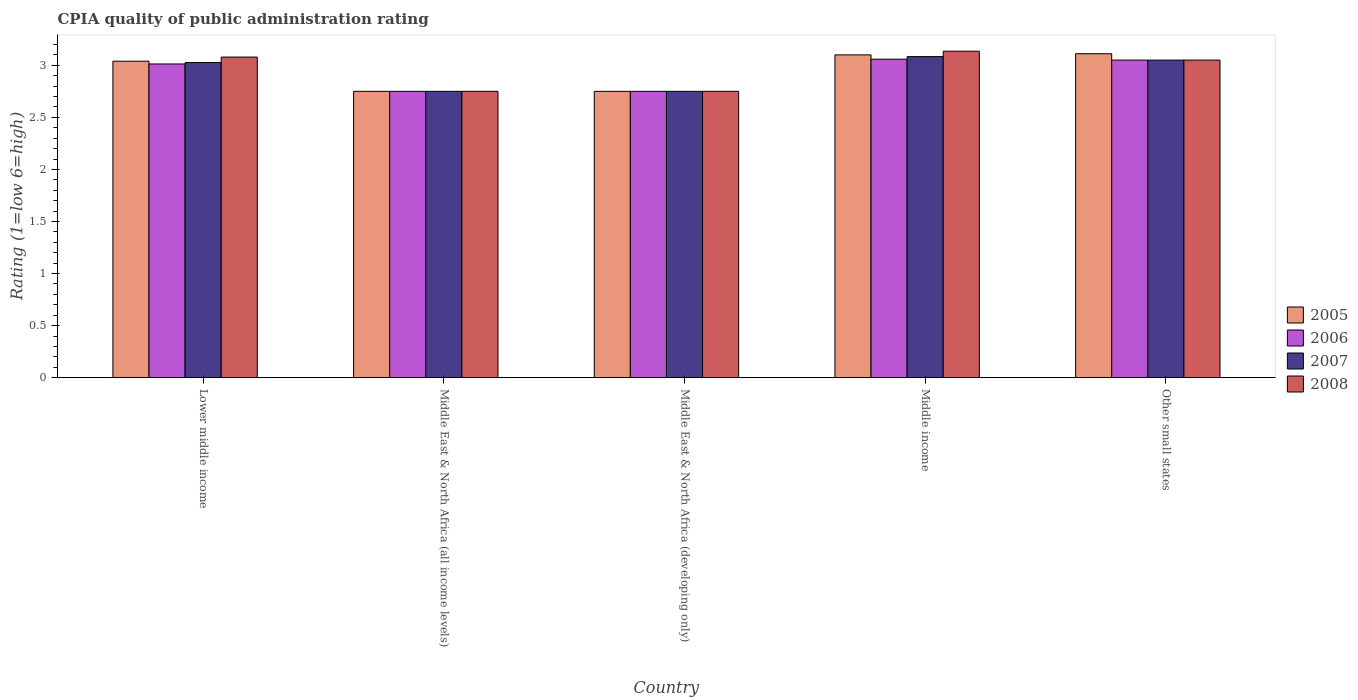What is the label of the 4th group of bars from the left?
Provide a succinct answer. Middle income. What is the CPIA rating in 2006 in Middle income?
Your answer should be very brief. 3.06. Across all countries, what is the maximum CPIA rating in 2008?
Your answer should be compact. 3.14. Across all countries, what is the minimum CPIA rating in 2006?
Make the answer very short. 2.75. In which country was the CPIA rating in 2007 maximum?
Your answer should be very brief. Middle income. In which country was the CPIA rating in 2008 minimum?
Make the answer very short. Middle East & North Africa (all income levels). What is the total CPIA rating in 2008 in the graph?
Offer a terse response. 14.76. What is the difference between the CPIA rating in 2008 in Middle East & North Africa (all income levels) and that in Other small states?
Your answer should be very brief. -0.3. What is the difference between the CPIA rating in 2006 in Middle income and the CPIA rating in 2005 in Other small states?
Keep it short and to the point. -0.05. What is the average CPIA rating in 2007 per country?
Your answer should be very brief. 2.93. What is the difference between the CPIA rating of/in 2007 and CPIA rating of/in 2005 in Middle East & North Africa (all income levels)?
Your response must be concise. 0. What is the ratio of the CPIA rating in 2007 in Lower middle income to that in Middle income?
Provide a short and direct response. 0.98. Is the CPIA rating in 2005 in Middle East & North Africa (developing only) less than that in Middle income?
Provide a succinct answer. Yes. Is the difference between the CPIA rating in 2007 in Lower middle income and Middle East & North Africa (developing only) greater than the difference between the CPIA rating in 2005 in Lower middle income and Middle East & North Africa (developing only)?
Offer a terse response. No. What is the difference between the highest and the second highest CPIA rating in 2006?
Your response must be concise. -0.01. What is the difference between the highest and the lowest CPIA rating in 2006?
Offer a very short reply. 0.31. Is the sum of the CPIA rating in 2008 in Middle East & North Africa (all income levels) and Other small states greater than the maximum CPIA rating in 2005 across all countries?
Ensure brevity in your answer.  Yes. Is it the case that in every country, the sum of the CPIA rating in 2006 and CPIA rating in 2005 is greater than the sum of CPIA rating in 2008 and CPIA rating in 2007?
Provide a succinct answer. No. What does the 1st bar from the left in Lower middle income represents?
Provide a short and direct response. 2005. How many bars are there?
Keep it short and to the point. 20. How many countries are there in the graph?
Provide a succinct answer. 5. Are the values on the major ticks of Y-axis written in scientific E-notation?
Make the answer very short. No. Does the graph contain any zero values?
Make the answer very short. No. Where does the legend appear in the graph?
Your response must be concise. Center right. How many legend labels are there?
Your response must be concise. 4. What is the title of the graph?
Your answer should be very brief. CPIA quality of public administration rating. Does "1997" appear as one of the legend labels in the graph?
Ensure brevity in your answer.  No. What is the label or title of the Y-axis?
Give a very brief answer. Rating (1=low 6=high). What is the Rating (1=low 6=high) in 2005 in Lower middle income?
Your answer should be compact. 3.04. What is the Rating (1=low 6=high) of 2006 in Lower middle income?
Give a very brief answer. 3.01. What is the Rating (1=low 6=high) of 2007 in Lower middle income?
Ensure brevity in your answer.  3.03. What is the Rating (1=low 6=high) of 2008 in Lower middle income?
Offer a terse response. 3.08. What is the Rating (1=low 6=high) of 2005 in Middle East & North Africa (all income levels)?
Make the answer very short. 2.75. What is the Rating (1=low 6=high) in 2006 in Middle East & North Africa (all income levels)?
Offer a terse response. 2.75. What is the Rating (1=low 6=high) of 2007 in Middle East & North Africa (all income levels)?
Your answer should be compact. 2.75. What is the Rating (1=low 6=high) in 2008 in Middle East & North Africa (all income levels)?
Your answer should be compact. 2.75. What is the Rating (1=low 6=high) in 2005 in Middle East & North Africa (developing only)?
Offer a very short reply. 2.75. What is the Rating (1=low 6=high) of 2006 in Middle East & North Africa (developing only)?
Offer a terse response. 2.75. What is the Rating (1=low 6=high) in 2007 in Middle East & North Africa (developing only)?
Keep it short and to the point. 2.75. What is the Rating (1=low 6=high) in 2008 in Middle East & North Africa (developing only)?
Provide a short and direct response. 2.75. What is the Rating (1=low 6=high) in 2005 in Middle income?
Offer a terse response. 3.1. What is the Rating (1=low 6=high) of 2006 in Middle income?
Your answer should be compact. 3.06. What is the Rating (1=low 6=high) of 2007 in Middle income?
Make the answer very short. 3.08. What is the Rating (1=low 6=high) in 2008 in Middle income?
Keep it short and to the point. 3.14. What is the Rating (1=low 6=high) in 2005 in Other small states?
Offer a terse response. 3.11. What is the Rating (1=low 6=high) of 2006 in Other small states?
Keep it short and to the point. 3.05. What is the Rating (1=low 6=high) in 2007 in Other small states?
Keep it short and to the point. 3.05. What is the Rating (1=low 6=high) in 2008 in Other small states?
Ensure brevity in your answer.  3.05. Across all countries, what is the maximum Rating (1=low 6=high) of 2005?
Keep it short and to the point. 3.11. Across all countries, what is the maximum Rating (1=low 6=high) of 2006?
Keep it short and to the point. 3.06. Across all countries, what is the maximum Rating (1=low 6=high) in 2007?
Your answer should be very brief. 3.08. Across all countries, what is the maximum Rating (1=low 6=high) of 2008?
Your answer should be very brief. 3.14. Across all countries, what is the minimum Rating (1=low 6=high) of 2005?
Ensure brevity in your answer.  2.75. Across all countries, what is the minimum Rating (1=low 6=high) in 2006?
Keep it short and to the point. 2.75. Across all countries, what is the minimum Rating (1=low 6=high) of 2007?
Offer a very short reply. 2.75. Across all countries, what is the minimum Rating (1=low 6=high) in 2008?
Provide a succinct answer. 2.75. What is the total Rating (1=low 6=high) of 2005 in the graph?
Offer a very short reply. 14.75. What is the total Rating (1=low 6=high) of 2006 in the graph?
Offer a terse response. 14.62. What is the total Rating (1=low 6=high) in 2007 in the graph?
Provide a short and direct response. 14.66. What is the total Rating (1=low 6=high) of 2008 in the graph?
Your answer should be compact. 14.76. What is the difference between the Rating (1=low 6=high) of 2005 in Lower middle income and that in Middle East & North Africa (all income levels)?
Offer a terse response. 0.29. What is the difference between the Rating (1=low 6=high) of 2006 in Lower middle income and that in Middle East & North Africa (all income levels)?
Offer a terse response. 0.26. What is the difference between the Rating (1=low 6=high) of 2007 in Lower middle income and that in Middle East & North Africa (all income levels)?
Offer a terse response. 0.28. What is the difference between the Rating (1=low 6=high) of 2008 in Lower middle income and that in Middle East & North Africa (all income levels)?
Your answer should be compact. 0.33. What is the difference between the Rating (1=low 6=high) in 2005 in Lower middle income and that in Middle East & North Africa (developing only)?
Your answer should be very brief. 0.29. What is the difference between the Rating (1=low 6=high) in 2006 in Lower middle income and that in Middle East & North Africa (developing only)?
Your response must be concise. 0.26. What is the difference between the Rating (1=low 6=high) of 2007 in Lower middle income and that in Middle East & North Africa (developing only)?
Make the answer very short. 0.28. What is the difference between the Rating (1=low 6=high) in 2008 in Lower middle income and that in Middle East & North Africa (developing only)?
Offer a terse response. 0.33. What is the difference between the Rating (1=low 6=high) of 2005 in Lower middle income and that in Middle income?
Offer a terse response. -0.06. What is the difference between the Rating (1=low 6=high) in 2006 in Lower middle income and that in Middle income?
Provide a short and direct response. -0.05. What is the difference between the Rating (1=low 6=high) of 2007 in Lower middle income and that in Middle income?
Keep it short and to the point. -0.06. What is the difference between the Rating (1=low 6=high) of 2008 in Lower middle income and that in Middle income?
Make the answer very short. -0.06. What is the difference between the Rating (1=low 6=high) in 2005 in Lower middle income and that in Other small states?
Give a very brief answer. -0.07. What is the difference between the Rating (1=low 6=high) in 2006 in Lower middle income and that in Other small states?
Offer a very short reply. -0.04. What is the difference between the Rating (1=low 6=high) of 2007 in Lower middle income and that in Other small states?
Your answer should be compact. -0.02. What is the difference between the Rating (1=low 6=high) of 2008 in Lower middle income and that in Other small states?
Provide a short and direct response. 0.03. What is the difference between the Rating (1=low 6=high) of 2006 in Middle East & North Africa (all income levels) and that in Middle East & North Africa (developing only)?
Offer a very short reply. 0. What is the difference between the Rating (1=low 6=high) in 2007 in Middle East & North Africa (all income levels) and that in Middle East & North Africa (developing only)?
Provide a succinct answer. 0. What is the difference between the Rating (1=low 6=high) of 2005 in Middle East & North Africa (all income levels) and that in Middle income?
Your answer should be compact. -0.35. What is the difference between the Rating (1=low 6=high) in 2006 in Middle East & North Africa (all income levels) and that in Middle income?
Your answer should be very brief. -0.31. What is the difference between the Rating (1=low 6=high) in 2007 in Middle East & North Africa (all income levels) and that in Middle income?
Keep it short and to the point. -0.33. What is the difference between the Rating (1=low 6=high) in 2008 in Middle East & North Africa (all income levels) and that in Middle income?
Make the answer very short. -0.39. What is the difference between the Rating (1=low 6=high) in 2005 in Middle East & North Africa (all income levels) and that in Other small states?
Keep it short and to the point. -0.36. What is the difference between the Rating (1=low 6=high) of 2006 in Middle East & North Africa (all income levels) and that in Other small states?
Offer a terse response. -0.3. What is the difference between the Rating (1=low 6=high) in 2007 in Middle East & North Africa (all income levels) and that in Other small states?
Your answer should be compact. -0.3. What is the difference between the Rating (1=low 6=high) of 2005 in Middle East & North Africa (developing only) and that in Middle income?
Ensure brevity in your answer.  -0.35. What is the difference between the Rating (1=low 6=high) of 2006 in Middle East & North Africa (developing only) and that in Middle income?
Make the answer very short. -0.31. What is the difference between the Rating (1=low 6=high) in 2008 in Middle East & North Africa (developing only) and that in Middle income?
Offer a terse response. -0.39. What is the difference between the Rating (1=low 6=high) of 2005 in Middle East & North Africa (developing only) and that in Other small states?
Make the answer very short. -0.36. What is the difference between the Rating (1=low 6=high) in 2008 in Middle East & North Africa (developing only) and that in Other small states?
Offer a very short reply. -0.3. What is the difference between the Rating (1=low 6=high) in 2005 in Middle income and that in Other small states?
Provide a succinct answer. -0.01. What is the difference between the Rating (1=low 6=high) in 2006 in Middle income and that in Other small states?
Make the answer very short. 0.01. What is the difference between the Rating (1=low 6=high) in 2007 in Middle income and that in Other small states?
Provide a succinct answer. 0.03. What is the difference between the Rating (1=low 6=high) in 2008 in Middle income and that in Other small states?
Your response must be concise. 0.09. What is the difference between the Rating (1=low 6=high) in 2005 in Lower middle income and the Rating (1=low 6=high) in 2006 in Middle East & North Africa (all income levels)?
Provide a succinct answer. 0.29. What is the difference between the Rating (1=low 6=high) of 2005 in Lower middle income and the Rating (1=low 6=high) of 2007 in Middle East & North Africa (all income levels)?
Offer a very short reply. 0.29. What is the difference between the Rating (1=low 6=high) of 2005 in Lower middle income and the Rating (1=low 6=high) of 2008 in Middle East & North Africa (all income levels)?
Provide a succinct answer. 0.29. What is the difference between the Rating (1=low 6=high) of 2006 in Lower middle income and the Rating (1=low 6=high) of 2007 in Middle East & North Africa (all income levels)?
Your response must be concise. 0.26. What is the difference between the Rating (1=low 6=high) in 2006 in Lower middle income and the Rating (1=low 6=high) in 2008 in Middle East & North Africa (all income levels)?
Offer a terse response. 0.26. What is the difference between the Rating (1=low 6=high) in 2007 in Lower middle income and the Rating (1=low 6=high) in 2008 in Middle East & North Africa (all income levels)?
Give a very brief answer. 0.28. What is the difference between the Rating (1=low 6=high) in 2005 in Lower middle income and the Rating (1=low 6=high) in 2006 in Middle East & North Africa (developing only)?
Offer a terse response. 0.29. What is the difference between the Rating (1=low 6=high) in 2005 in Lower middle income and the Rating (1=low 6=high) in 2007 in Middle East & North Africa (developing only)?
Keep it short and to the point. 0.29. What is the difference between the Rating (1=low 6=high) of 2005 in Lower middle income and the Rating (1=low 6=high) of 2008 in Middle East & North Africa (developing only)?
Your answer should be compact. 0.29. What is the difference between the Rating (1=low 6=high) in 2006 in Lower middle income and the Rating (1=low 6=high) in 2007 in Middle East & North Africa (developing only)?
Provide a succinct answer. 0.26. What is the difference between the Rating (1=low 6=high) in 2006 in Lower middle income and the Rating (1=low 6=high) in 2008 in Middle East & North Africa (developing only)?
Provide a short and direct response. 0.26. What is the difference between the Rating (1=low 6=high) of 2007 in Lower middle income and the Rating (1=low 6=high) of 2008 in Middle East & North Africa (developing only)?
Ensure brevity in your answer.  0.28. What is the difference between the Rating (1=low 6=high) of 2005 in Lower middle income and the Rating (1=low 6=high) of 2006 in Middle income?
Offer a very short reply. -0.02. What is the difference between the Rating (1=low 6=high) in 2005 in Lower middle income and the Rating (1=low 6=high) in 2007 in Middle income?
Provide a succinct answer. -0.04. What is the difference between the Rating (1=low 6=high) in 2005 in Lower middle income and the Rating (1=low 6=high) in 2008 in Middle income?
Give a very brief answer. -0.1. What is the difference between the Rating (1=low 6=high) in 2006 in Lower middle income and the Rating (1=low 6=high) in 2007 in Middle income?
Ensure brevity in your answer.  -0.07. What is the difference between the Rating (1=low 6=high) in 2006 in Lower middle income and the Rating (1=low 6=high) in 2008 in Middle income?
Make the answer very short. -0.12. What is the difference between the Rating (1=low 6=high) in 2007 in Lower middle income and the Rating (1=low 6=high) in 2008 in Middle income?
Ensure brevity in your answer.  -0.11. What is the difference between the Rating (1=low 6=high) of 2005 in Lower middle income and the Rating (1=low 6=high) of 2006 in Other small states?
Your answer should be compact. -0.01. What is the difference between the Rating (1=low 6=high) in 2005 in Lower middle income and the Rating (1=low 6=high) in 2007 in Other small states?
Your answer should be compact. -0.01. What is the difference between the Rating (1=low 6=high) in 2005 in Lower middle income and the Rating (1=low 6=high) in 2008 in Other small states?
Keep it short and to the point. -0.01. What is the difference between the Rating (1=low 6=high) in 2006 in Lower middle income and the Rating (1=low 6=high) in 2007 in Other small states?
Keep it short and to the point. -0.04. What is the difference between the Rating (1=low 6=high) of 2006 in Lower middle income and the Rating (1=low 6=high) of 2008 in Other small states?
Provide a succinct answer. -0.04. What is the difference between the Rating (1=low 6=high) of 2007 in Lower middle income and the Rating (1=low 6=high) of 2008 in Other small states?
Your answer should be compact. -0.02. What is the difference between the Rating (1=low 6=high) of 2006 in Middle East & North Africa (all income levels) and the Rating (1=low 6=high) of 2007 in Middle East & North Africa (developing only)?
Provide a succinct answer. 0. What is the difference between the Rating (1=low 6=high) of 2006 in Middle East & North Africa (all income levels) and the Rating (1=low 6=high) of 2008 in Middle East & North Africa (developing only)?
Your response must be concise. 0. What is the difference between the Rating (1=low 6=high) of 2005 in Middle East & North Africa (all income levels) and the Rating (1=low 6=high) of 2006 in Middle income?
Your answer should be compact. -0.31. What is the difference between the Rating (1=low 6=high) in 2005 in Middle East & North Africa (all income levels) and the Rating (1=low 6=high) in 2008 in Middle income?
Provide a short and direct response. -0.39. What is the difference between the Rating (1=low 6=high) in 2006 in Middle East & North Africa (all income levels) and the Rating (1=low 6=high) in 2008 in Middle income?
Your answer should be compact. -0.39. What is the difference between the Rating (1=low 6=high) of 2007 in Middle East & North Africa (all income levels) and the Rating (1=low 6=high) of 2008 in Middle income?
Offer a very short reply. -0.39. What is the difference between the Rating (1=low 6=high) of 2005 in Middle East & North Africa (all income levels) and the Rating (1=low 6=high) of 2006 in Other small states?
Keep it short and to the point. -0.3. What is the difference between the Rating (1=low 6=high) of 2005 in Middle East & North Africa (all income levels) and the Rating (1=low 6=high) of 2007 in Other small states?
Offer a terse response. -0.3. What is the difference between the Rating (1=low 6=high) in 2005 in Middle East & North Africa (developing only) and the Rating (1=low 6=high) in 2006 in Middle income?
Make the answer very short. -0.31. What is the difference between the Rating (1=low 6=high) of 2005 in Middle East & North Africa (developing only) and the Rating (1=low 6=high) of 2008 in Middle income?
Provide a short and direct response. -0.39. What is the difference between the Rating (1=low 6=high) of 2006 in Middle East & North Africa (developing only) and the Rating (1=low 6=high) of 2007 in Middle income?
Your answer should be compact. -0.33. What is the difference between the Rating (1=low 6=high) of 2006 in Middle East & North Africa (developing only) and the Rating (1=low 6=high) of 2008 in Middle income?
Your response must be concise. -0.39. What is the difference between the Rating (1=low 6=high) in 2007 in Middle East & North Africa (developing only) and the Rating (1=low 6=high) in 2008 in Middle income?
Keep it short and to the point. -0.39. What is the difference between the Rating (1=low 6=high) in 2005 in Middle East & North Africa (developing only) and the Rating (1=low 6=high) in 2006 in Other small states?
Your answer should be compact. -0.3. What is the difference between the Rating (1=low 6=high) of 2005 in Middle East & North Africa (developing only) and the Rating (1=low 6=high) of 2007 in Other small states?
Your response must be concise. -0.3. What is the difference between the Rating (1=low 6=high) of 2005 in Middle East & North Africa (developing only) and the Rating (1=low 6=high) of 2008 in Other small states?
Keep it short and to the point. -0.3. What is the difference between the Rating (1=low 6=high) in 2006 in Middle East & North Africa (developing only) and the Rating (1=low 6=high) in 2007 in Other small states?
Keep it short and to the point. -0.3. What is the difference between the Rating (1=low 6=high) of 2006 in Middle East & North Africa (developing only) and the Rating (1=low 6=high) of 2008 in Other small states?
Offer a terse response. -0.3. What is the difference between the Rating (1=low 6=high) in 2007 in Middle East & North Africa (developing only) and the Rating (1=low 6=high) in 2008 in Other small states?
Make the answer very short. -0.3. What is the difference between the Rating (1=low 6=high) in 2005 in Middle income and the Rating (1=low 6=high) in 2007 in Other small states?
Provide a succinct answer. 0.05. What is the difference between the Rating (1=low 6=high) in 2006 in Middle income and the Rating (1=low 6=high) in 2007 in Other small states?
Keep it short and to the point. 0.01. What is the difference between the Rating (1=low 6=high) of 2006 in Middle income and the Rating (1=low 6=high) of 2008 in Other small states?
Offer a terse response. 0.01. What is the average Rating (1=low 6=high) of 2005 per country?
Provide a succinct answer. 2.95. What is the average Rating (1=low 6=high) of 2006 per country?
Keep it short and to the point. 2.92. What is the average Rating (1=low 6=high) in 2007 per country?
Give a very brief answer. 2.93. What is the average Rating (1=low 6=high) of 2008 per country?
Your answer should be compact. 2.95. What is the difference between the Rating (1=low 6=high) of 2005 and Rating (1=low 6=high) of 2006 in Lower middle income?
Make the answer very short. 0.03. What is the difference between the Rating (1=low 6=high) of 2005 and Rating (1=low 6=high) of 2007 in Lower middle income?
Offer a very short reply. 0.01. What is the difference between the Rating (1=low 6=high) in 2005 and Rating (1=low 6=high) in 2008 in Lower middle income?
Your response must be concise. -0.04. What is the difference between the Rating (1=low 6=high) of 2006 and Rating (1=low 6=high) of 2007 in Lower middle income?
Your response must be concise. -0.01. What is the difference between the Rating (1=low 6=high) in 2006 and Rating (1=low 6=high) in 2008 in Lower middle income?
Ensure brevity in your answer.  -0.07. What is the difference between the Rating (1=low 6=high) in 2007 and Rating (1=low 6=high) in 2008 in Lower middle income?
Ensure brevity in your answer.  -0.05. What is the difference between the Rating (1=low 6=high) of 2005 and Rating (1=low 6=high) of 2007 in Middle East & North Africa (all income levels)?
Your answer should be very brief. 0. What is the difference between the Rating (1=low 6=high) of 2005 and Rating (1=low 6=high) of 2008 in Middle East & North Africa (all income levels)?
Provide a succinct answer. 0. What is the difference between the Rating (1=low 6=high) of 2006 and Rating (1=low 6=high) of 2007 in Middle East & North Africa (all income levels)?
Provide a succinct answer. 0. What is the difference between the Rating (1=low 6=high) of 2007 and Rating (1=low 6=high) of 2008 in Middle East & North Africa (all income levels)?
Provide a succinct answer. 0. What is the difference between the Rating (1=low 6=high) in 2006 and Rating (1=low 6=high) in 2007 in Middle East & North Africa (developing only)?
Offer a very short reply. 0. What is the difference between the Rating (1=low 6=high) in 2005 and Rating (1=low 6=high) in 2006 in Middle income?
Your answer should be very brief. 0.04. What is the difference between the Rating (1=low 6=high) in 2005 and Rating (1=low 6=high) in 2007 in Middle income?
Your response must be concise. 0.02. What is the difference between the Rating (1=low 6=high) in 2005 and Rating (1=low 6=high) in 2008 in Middle income?
Ensure brevity in your answer.  -0.04. What is the difference between the Rating (1=low 6=high) of 2006 and Rating (1=low 6=high) of 2007 in Middle income?
Provide a succinct answer. -0.02. What is the difference between the Rating (1=low 6=high) of 2006 and Rating (1=low 6=high) of 2008 in Middle income?
Provide a succinct answer. -0.08. What is the difference between the Rating (1=low 6=high) in 2007 and Rating (1=low 6=high) in 2008 in Middle income?
Your response must be concise. -0.05. What is the difference between the Rating (1=low 6=high) of 2005 and Rating (1=low 6=high) of 2006 in Other small states?
Keep it short and to the point. 0.06. What is the difference between the Rating (1=low 6=high) of 2005 and Rating (1=low 6=high) of 2007 in Other small states?
Provide a short and direct response. 0.06. What is the difference between the Rating (1=low 6=high) in 2005 and Rating (1=low 6=high) in 2008 in Other small states?
Give a very brief answer. 0.06. What is the difference between the Rating (1=low 6=high) of 2006 and Rating (1=low 6=high) of 2007 in Other small states?
Your answer should be compact. 0. What is the difference between the Rating (1=low 6=high) in 2007 and Rating (1=low 6=high) in 2008 in Other small states?
Keep it short and to the point. 0. What is the ratio of the Rating (1=low 6=high) of 2005 in Lower middle income to that in Middle East & North Africa (all income levels)?
Provide a succinct answer. 1.11. What is the ratio of the Rating (1=low 6=high) of 2006 in Lower middle income to that in Middle East & North Africa (all income levels)?
Keep it short and to the point. 1.1. What is the ratio of the Rating (1=low 6=high) in 2007 in Lower middle income to that in Middle East & North Africa (all income levels)?
Offer a very short reply. 1.1. What is the ratio of the Rating (1=low 6=high) of 2008 in Lower middle income to that in Middle East & North Africa (all income levels)?
Your answer should be compact. 1.12. What is the ratio of the Rating (1=low 6=high) of 2005 in Lower middle income to that in Middle East & North Africa (developing only)?
Provide a short and direct response. 1.11. What is the ratio of the Rating (1=low 6=high) in 2006 in Lower middle income to that in Middle East & North Africa (developing only)?
Your answer should be very brief. 1.1. What is the ratio of the Rating (1=low 6=high) of 2007 in Lower middle income to that in Middle East & North Africa (developing only)?
Offer a very short reply. 1.1. What is the ratio of the Rating (1=low 6=high) of 2008 in Lower middle income to that in Middle East & North Africa (developing only)?
Provide a short and direct response. 1.12. What is the ratio of the Rating (1=low 6=high) in 2005 in Lower middle income to that in Middle income?
Provide a short and direct response. 0.98. What is the ratio of the Rating (1=low 6=high) in 2006 in Lower middle income to that in Middle income?
Your answer should be very brief. 0.98. What is the ratio of the Rating (1=low 6=high) in 2007 in Lower middle income to that in Middle income?
Offer a very short reply. 0.98. What is the ratio of the Rating (1=low 6=high) of 2008 in Lower middle income to that in Middle income?
Your response must be concise. 0.98. What is the ratio of the Rating (1=low 6=high) of 2008 in Lower middle income to that in Other small states?
Offer a terse response. 1.01. What is the ratio of the Rating (1=low 6=high) in 2005 in Middle East & North Africa (all income levels) to that in Middle East & North Africa (developing only)?
Offer a very short reply. 1. What is the ratio of the Rating (1=low 6=high) of 2005 in Middle East & North Africa (all income levels) to that in Middle income?
Make the answer very short. 0.89. What is the ratio of the Rating (1=low 6=high) in 2006 in Middle East & North Africa (all income levels) to that in Middle income?
Your answer should be compact. 0.9. What is the ratio of the Rating (1=low 6=high) in 2007 in Middle East & North Africa (all income levels) to that in Middle income?
Offer a very short reply. 0.89. What is the ratio of the Rating (1=low 6=high) in 2008 in Middle East & North Africa (all income levels) to that in Middle income?
Offer a terse response. 0.88. What is the ratio of the Rating (1=low 6=high) of 2005 in Middle East & North Africa (all income levels) to that in Other small states?
Your answer should be compact. 0.88. What is the ratio of the Rating (1=low 6=high) of 2006 in Middle East & North Africa (all income levels) to that in Other small states?
Your answer should be compact. 0.9. What is the ratio of the Rating (1=low 6=high) of 2007 in Middle East & North Africa (all income levels) to that in Other small states?
Offer a very short reply. 0.9. What is the ratio of the Rating (1=low 6=high) of 2008 in Middle East & North Africa (all income levels) to that in Other small states?
Your answer should be very brief. 0.9. What is the ratio of the Rating (1=low 6=high) of 2005 in Middle East & North Africa (developing only) to that in Middle income?
Ensure brevity in your answer.  0.89. What is the ratio of the Rating (1=low 6=high) of 2006 in Middle East & North Africa (developing only) to that in Middle income?
Your response must be concise. 0.9. What is the ratio of the Rating (1=low 6=high) in 2007 in Middle East & North Africa (developing only) to that in Middle income?
Make the answer very short. 0.89. What is the ratio of the Rating (1=low 6=high) of 2008 in Middle East & North Africa (developing only) to that in Middle income?
Provide a short and direct response. 0.88. What is the ratio of the Rating (1=low 6=high) in 2005 in Middle East & North Africa (developing only) to that in Other small states?
Offer a terse response. 0.88. What is the ratio of the Rating (1=low 6=high) in 2006 in Middle East & North Africa (developing only) to that in Other small states?
Your answer should be compact. 0.9. What is the ratio of the Rating (1=low 6=high) in 2007 in Middle East & North Africa (developing only) to that in Other small states?
Provide a succinct answer. 0.9. What is the ratio of the Rating (1=low 6=high) in 2008 in Middle East & North Africa (developing only) to that in Other small states?
Offer a very short reply. 0.9. What is the ratio of the Rating (1=low 6=high) of 2007 in Middle income to that in Other small states?
Keep it short and to the point. 1.01. What is the ratio of the Rating (1=low 6=high) of 2008 in Middle income to that in Other small states?
Make the answer very short. 1.03. What is the difference between the highest and the second highest Rating (1=low 6=high) of 2005?
Keep it short and to the point. 0.01. What is the difference between the highest and the second highest Rating (1=low 6=high) in 2006?
Offer a terse response. 0.01. What is the difference between the highest and the second highest Rating (1=low 6=high) in 2007?
Your answer should be very brief. 0.03. What is the difference between the highest and the second highest Rating (1=low 6=high) in 2008?
Your answer should be very brief. 0.06. What is the difference between the highest and the lowest Rating (1=low 6=high) of 2005?
Provide a short and direct response. 0.36. What is the difference between the highest and the lowest Rating (1=low 6=high) of 2006?
Your answer should be compact. 0.31. What is the difference between the highest and the lowest Rating (1=low 6=high) of 2007?
Your answer should be compact. 0.33. What is the difference between the highest and the lowest Rating (1=low 6=high) in 2008?
Make the answer very short. 0.39. 